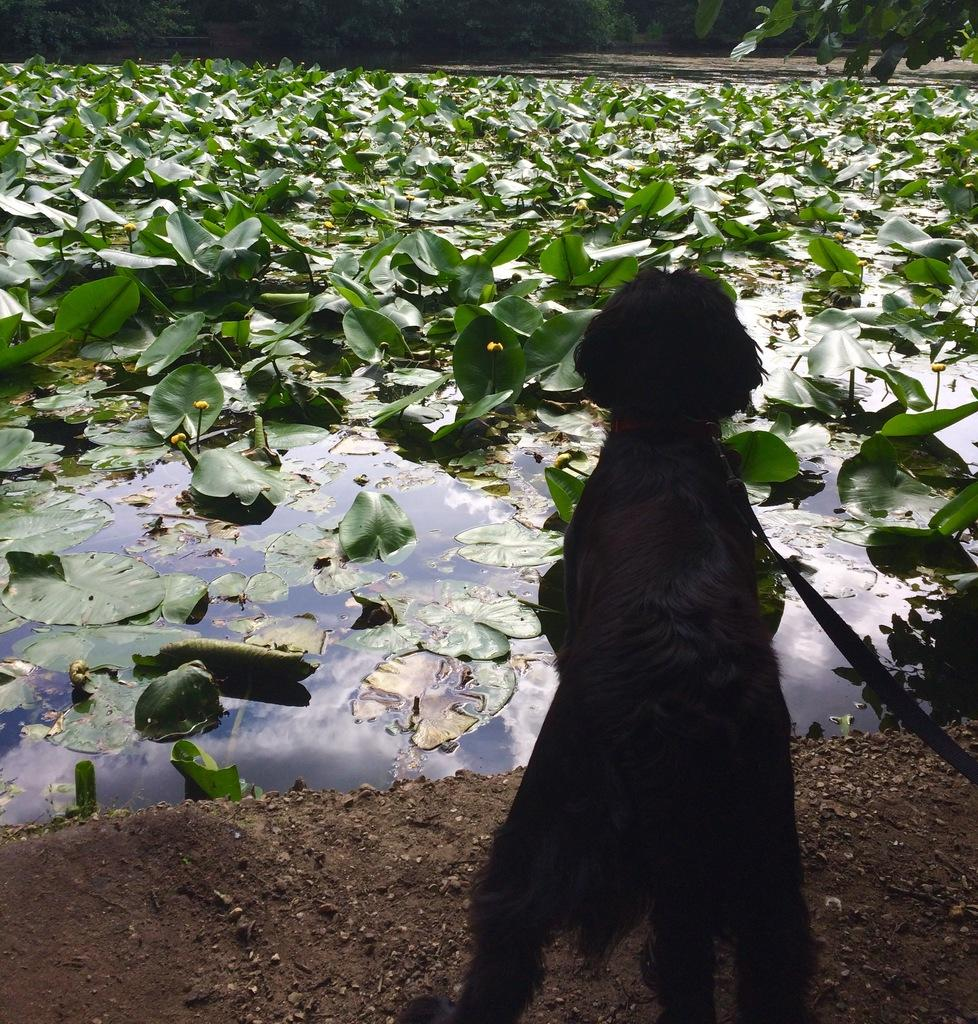What type of animal is in the image? There is a dog in the image. What is the dog wearing? The dog is wearing a belt. What can be seen in the background of the image? There are water plants, water, and trees visible in the background of the image. Where is the crowd gathered in the image? There is no crowd present in the image. What type of cake is being served in the image? There is no cake present in the image. 